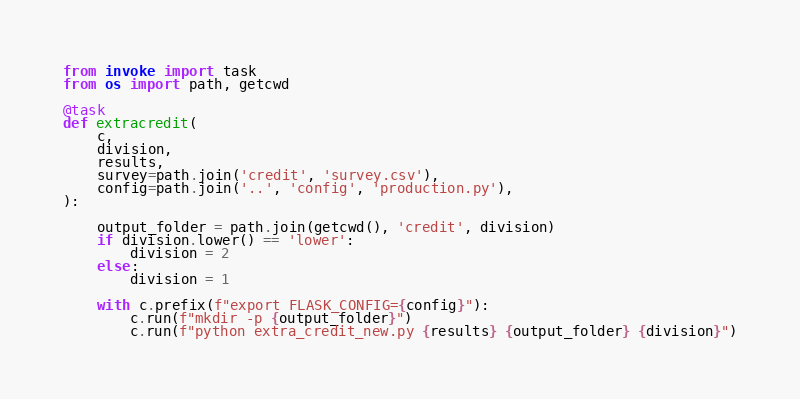<code> <loc_0><loc_0><loc_500><loc_500><_Python_>from invoke import task
from os import path, getcwd

@task
def extracredit(
    c,
    division,
    results,
    survey=path.join('credit', 'survey.csv'),
    config=path.join('..', 'config', 'production.py'),
):

    output_folder = path.join(getcwd(), 'credit', division)
    if division.lower() == 'lower':
        division = 2
    else:
        division = 1

    with c.prefix(f"export FLASK_CONFIG={config}"):
        c.run(f"mkdir -p {output_folder}")
        c.run(f"python extra_credit_new.py {results} {output_folder} {division}")

</code> 